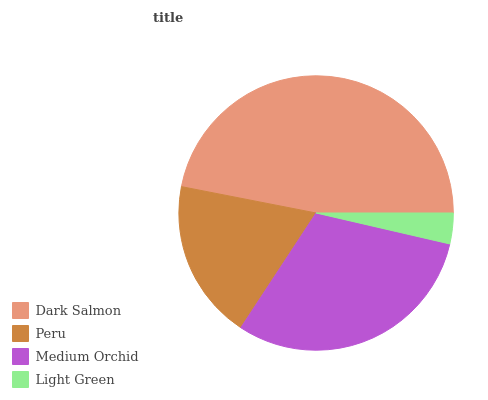Is Light Green the minimum?
Answer yes or no. Yes. Is Dark Salmon the maximum?
Answer yes or no. Yes. Is Peru the minimum?
Answer yes or no. No. Is Peru the maximum?
Answer yes or no. No. Is Dark Salmon greater than Peru?
Answer yes or no. Yes. Is Peru less than Dark Salmon?
Answer yes or no. Yes. Is Peru greater than Dark Salmon?
Answer yes or no. No. Is Dark Salmon less than Peru?
Answer yes or no. No. Is Medium Orchid the high median?
Answer yes or no. Yes. Is Peru the low median?
Answer yes or no. Yes. Is Peru the high median?
Answer yes or no. No. Is Light Green the low median?
Answer yes or no. No. 